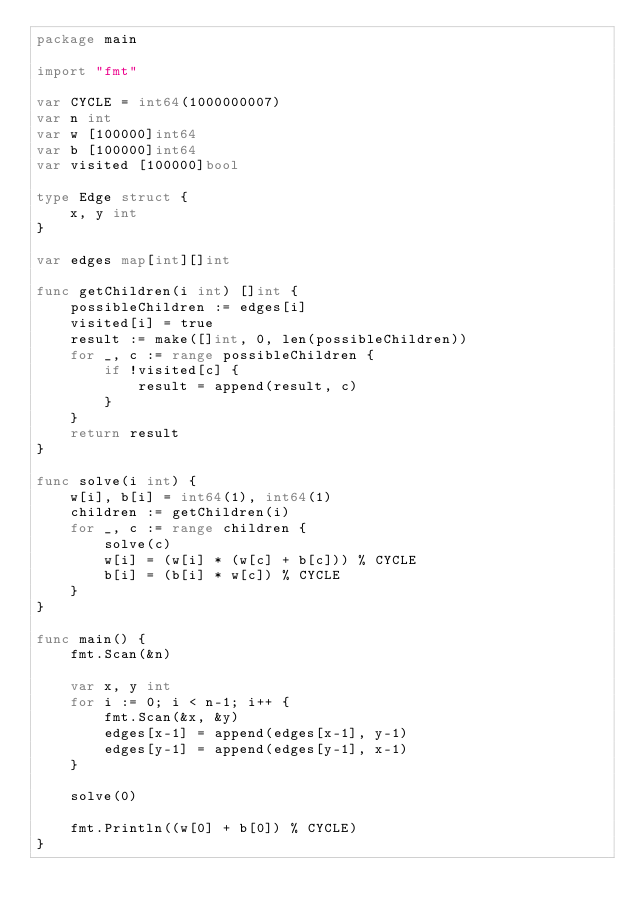<code> <loc_0><loc_0><loc_500><loc_500><_Go_>package main

import "fmt"

var CYCLE = int64(1000000007)
var n int
var w [100000]int64
var b [100000]int64
var visited [100000]bool

type Edge struct {
	x, y int
}

var edges map[int][]int

func getChildren(i int) []int {
	possibleChildren := edges[i]
	visited[i] = true
	result := make([]int, 0, len(possibleChildren))
	for _, c := range possibleChildren {
		if !visited[c] {
			result = append(result, c)
		}
	}
	return result
}

func solve(i int) {
	w[i], b[i] = int64(1), int64(1)
	children := getChildren(i)
	for _, c := range children {
		solve(c)
		w[i] = (w[i] * (w[c] + b[c])) % CYCLE
		b[i] = (b[i] * w[c]) % CYCLE
	}
}

func main() {
	fmt.Scan(&n)

	var x, y int
	for i := 0; i < n-1; i++ {
		fmt.Scan(&x, &y)
		edges[x-1] = append(edges[x-1], y-1)
		edges[y-1] = append(edges[y-1], x-1)
	}

	solve(0)

	fmt.Println((w[0] + b[0]) % CYCLE)
}
</code> 